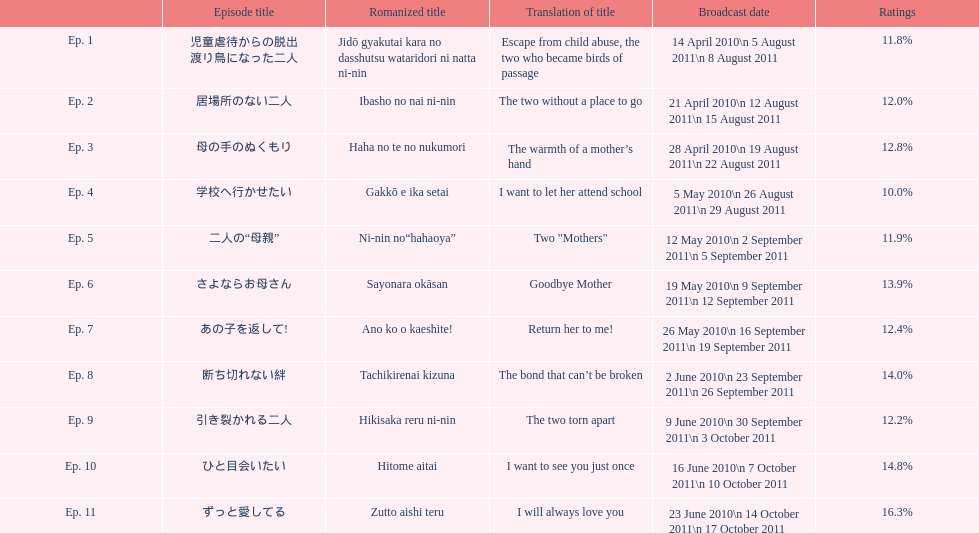What is the count of episodes with a percentage below 14%? 8. 